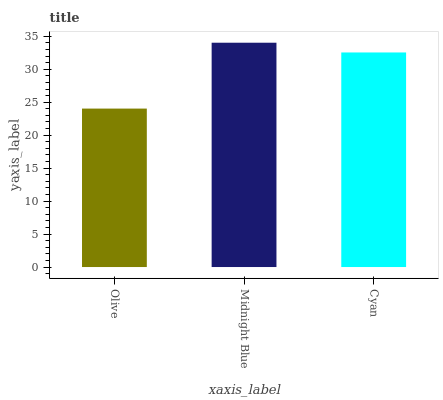Is Olive the minimum?
Answer yes or no. Yes. Is Midnight Blue the maximum?
Answer yes or no. Yes. Is Cyan the minimum?
Answer yes or no. No. Is Cyan the maximum?
Answer yes or no. No. Is Midnight Blue greater than Cyan?
Answer yes or no. Yes. Is Cyan less than Midnight Blue?
Answer yes or no. Yes. Is Cyan greater than Midnight Blue?
Answer yes or no. No. Is Midnight Blue less than Cyan?
Answer yes or no. No. Is Cyan the high median?
Answer yes or no. Yes. Is Cyan the low median?
Answer yes or no. Yes. Is Olive the high median?
Answer yes or no. No. Is Midnight Blue the low median?
Answer yes or no. No. 